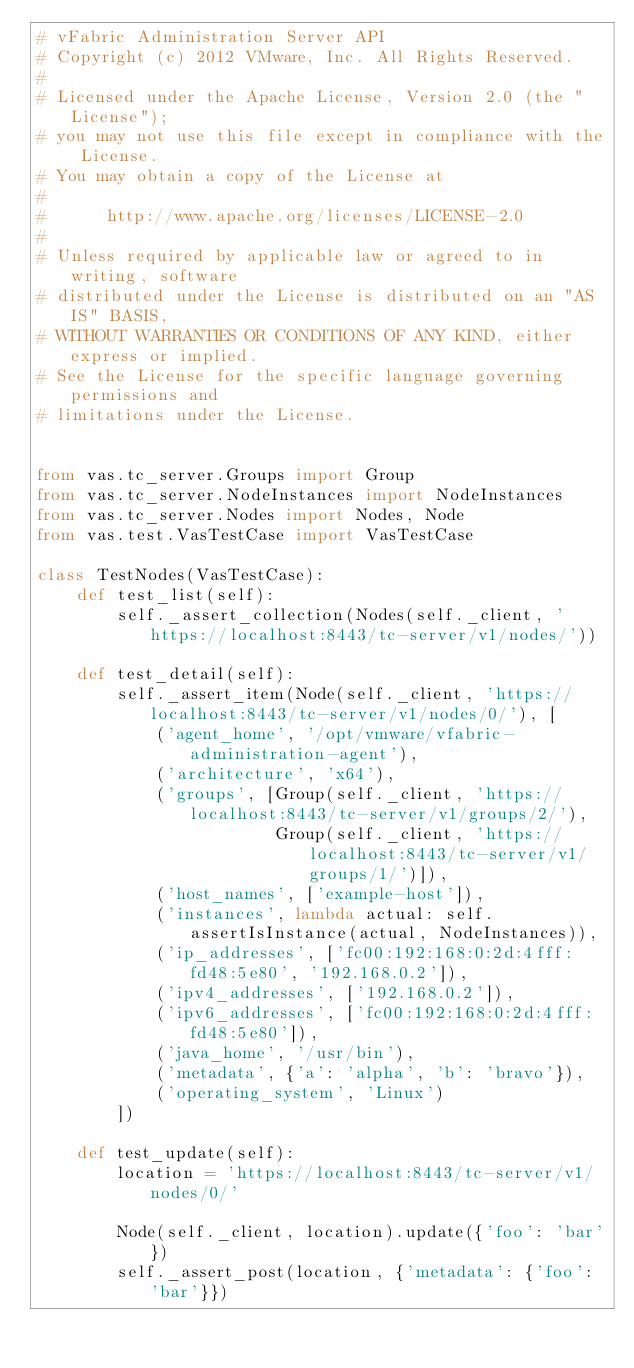<code> <loc_0><loc_0><loc_500><loc_500><_Python_># vFabric Administration Server API
# Copyright (c) 2012 VMware, Inc. All Rights Reserved.
#
# Licensed under the Apache License, Version 2.0 (the "License");
# you may not use this file except in compliance with the License.
# You may obtain a copy of the License at
#
#      http://www.apache.org/licenses/LICENSE-2.0
#
# Unless required by applicable law or agreed to in writing, software
# distributed under the License is distributed on an "AS IS" BASIS,
# WITHOUT WARRANTIES OR CONDITIONS OF ANY KIND, either express or implied.
# See the License for the specific language governing permissions and
# limitations under the License.


from vas.tc_server.Groups import Group
from vas.tc_server.NodeInstances import NodeInstances
from vas.tc_server.Nodes import Nodes, Node
from vas.test.VasTestCase import VasTestCase

class TestNodes(VasTestCase):
    def test_list(self):
        self._assert_collection(Nodes(self._client, 'https://localhost:8443/tc-server/v1/nodes/'))

    def test_detail(self):
        self._assert_item(Node(self._client, 'https://localhost:8443/tc-server/v1/nodes/0/'), [
            ('agent_home', '/opt/vmware/vfabric-administration-agent'),
            ('architecture', 'x64'),
            ('groups', [Group(self._client, 'https://localhost:8443/tc-server/v1/groups/2/'),
                        Group(self._client, 'https://localhost:8443/tc-server/v1/groups/1/')]),
            ('host_names', ['example-host']),
            ('instances', lambda actual: self.assertIsInstance(actual, NodeInstances)),
            ('ip_addresses', ['fc00:192:168:0:2d:4fff:fd48:5e80', '192.168.0.2']),
            ('ipv4_addresses', ['192.168.0.2']),
            ('ipv6_addresses', ['fc00:192:168:0:2d:4fff:fd48:5e80']),
            ('java_home', '/usr/bin'),
            ('metadata', {'a': 'alpha', 'b': 'bravo'}),
            ('operating_system', 'Linux')
        ])

    def test_update(self):
        location = 'https://localhost:8443/tc-server/v1/nodes/0/'

        Node(self._client, location).update({'foo': 'bar'})
        self._assert_post(location, {'metadata': {'foo': 'bar'}})
</code> 